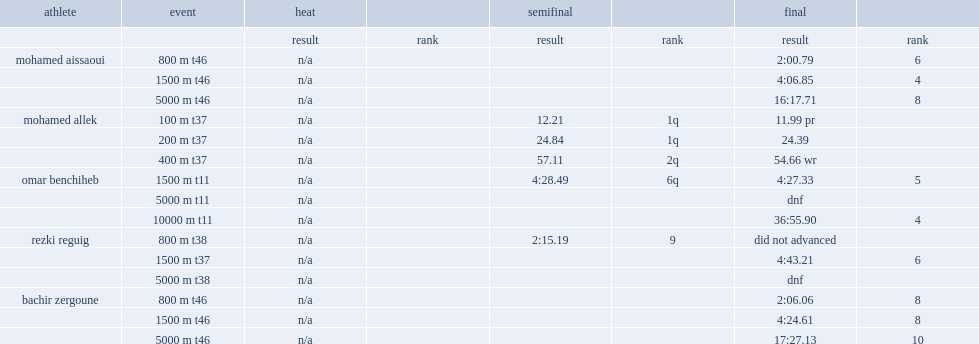In the 10,000 metre race, what the rank did omar benchiheb finish? 4.0. 